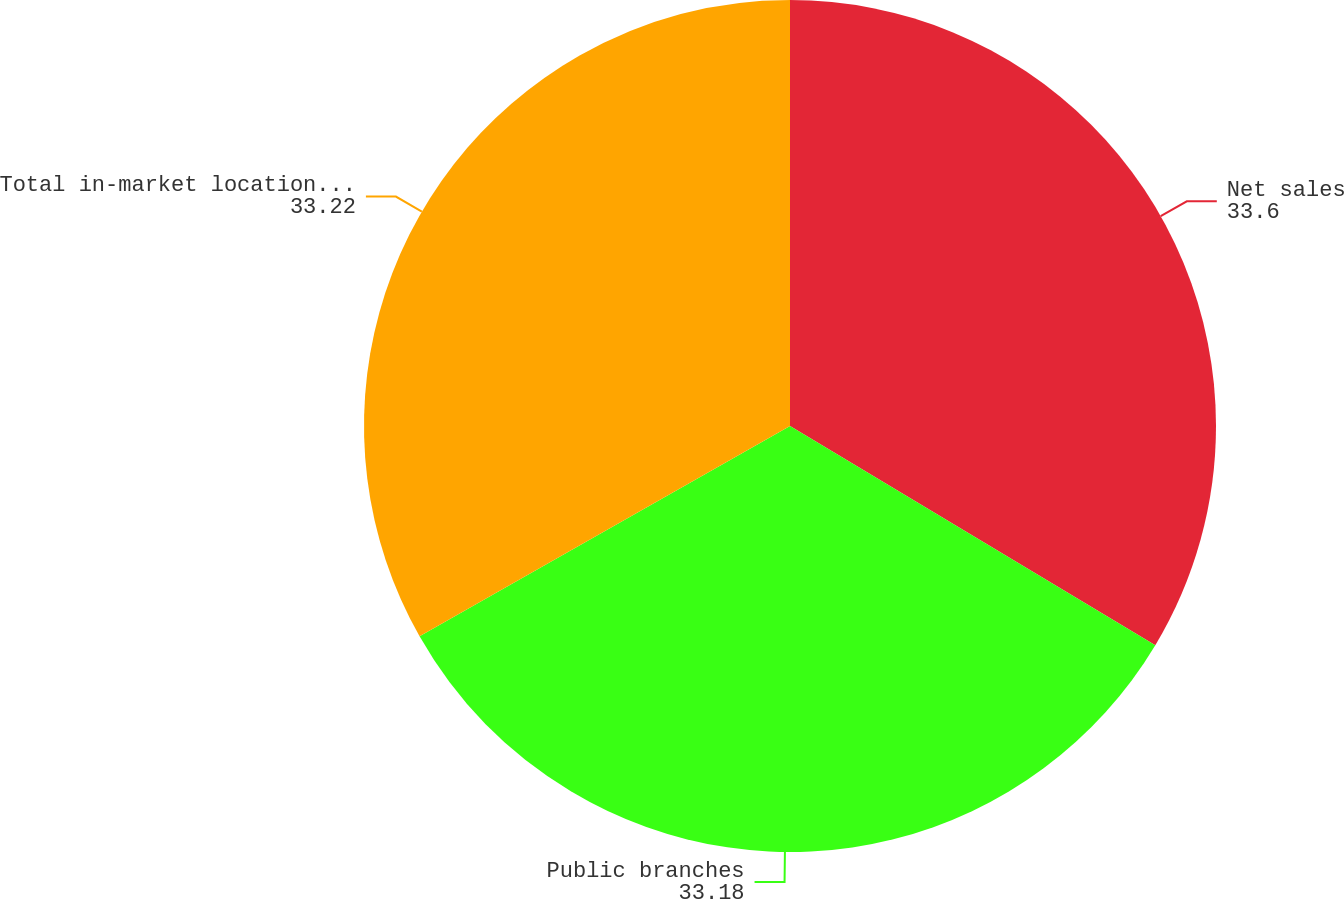<chart> <loc_0><loc_0><loc_500><loc_500><pie_chart><fcel>Net sales<fcel>Public branches<fcel>Total in-market locations (2)<nl><fcel>33.6%<fcel>33.18%<fcel>33.22%<nl></chart> 